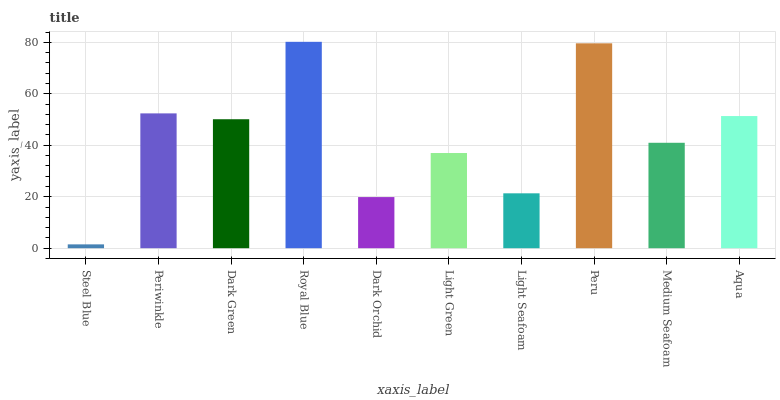Is Steel Blue the minimum?
Answer yes or no. Yes. Is Royal Blue the maximum?
Answer yes or no. Yes. Is Periwinkle the minimum?
Answer yes or no. No. Is Periwinkle the maximum?
Answer yes or no. No. Is Periwinkle greater than Steel Blue?
Answer yes or no. Yes. Is Steel Blue less than Periwinkle?
Answer yes or no. Yes. Is Steel Blue greater than Periwinkle?
Answer yes or no. No. Is Periwinkle less than Steel Blue?
Answer yes or no. No. Is Dark Green the high median?
Answer yes or no. Yes. Is Medium Seafoam the low median?
Answer yes or no. Yes. Is Periwinkle the high median?
Answer yes or no. No. Is Light Green the low median?
Answer yes or no. No. 